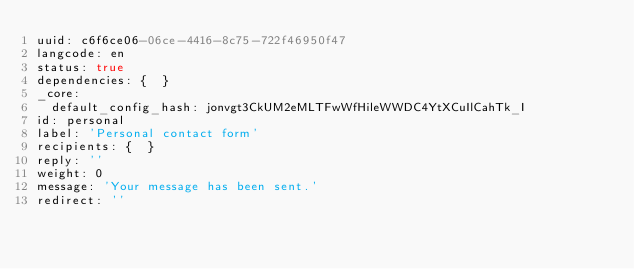<code> <loc_0><loc_0><loc_500><loc_500><_YAML_>uuid: c6f6ce06-06ce-4416-8c75-722f46950f47
langcode: en
status: true
dependencies: {  }
_core:
  default_config_hash: jonvgt3CkUM2eMLTFwWfHileWWDC4YtXCuIlCahTk_I
id: personal
label: 'Personal contact form'
recipients: {  }
reply: ''
weight: 0
message: 'Your message has been sent.'
redirect: ''
</code> 